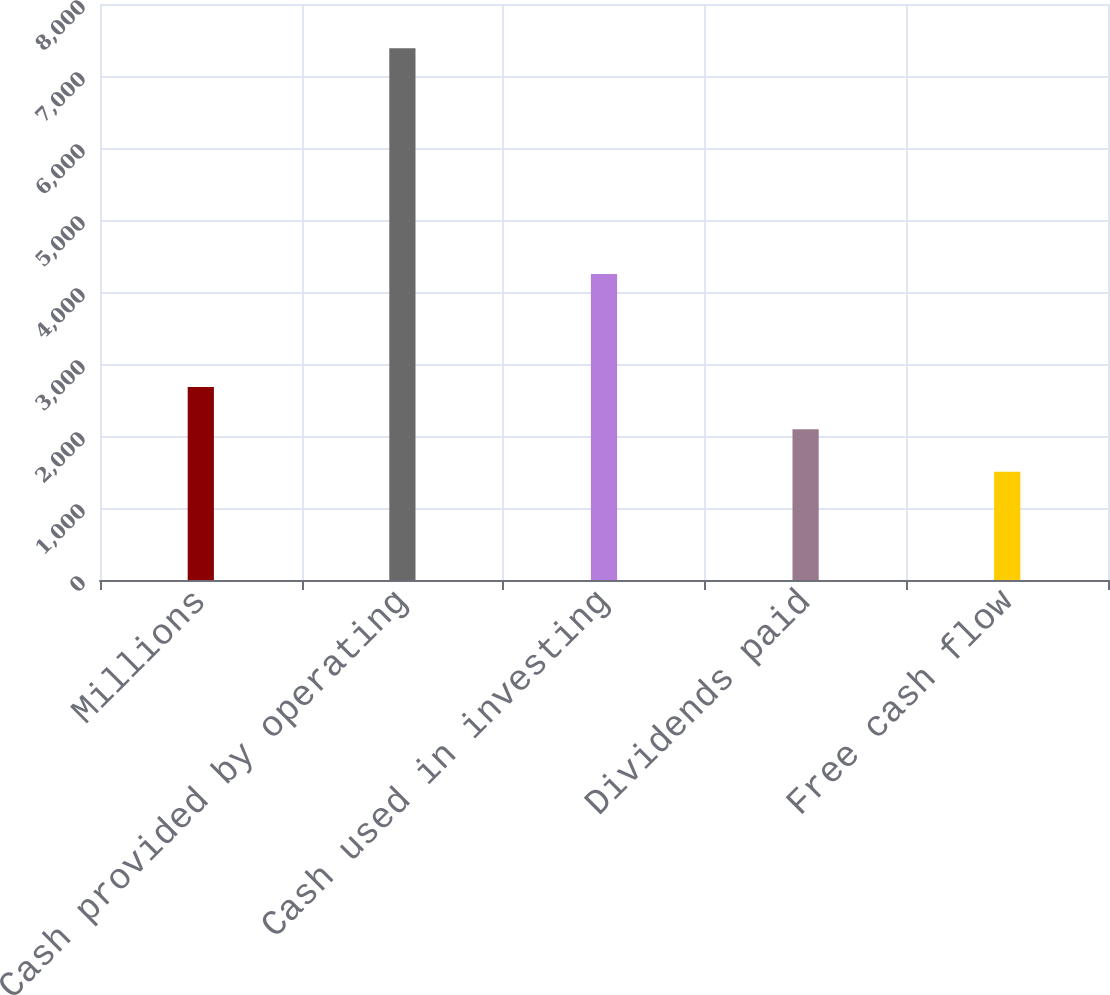Convert chart to OTSL. <chart><loc_0><loc_0><loc_500><loc_500><bar_chart><fcel>Millions<fcel>Cash provided by operating<fcel>Cash used in investing<fcel>Dividends paid<fcel>Free cash flow<nl><fcel>2680.2<fcel>7385<fcel>4249<fcel>2092.1<fcel>1504<nl></chart> 